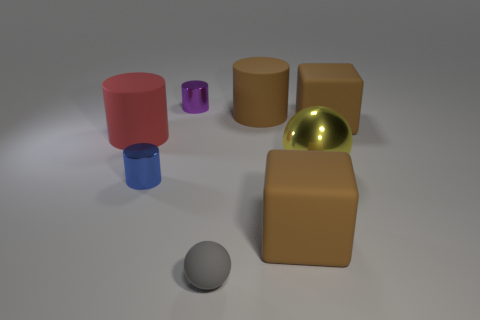In terms of spatial arrangement, how are the objects positioned relative to each other? The objects are scattered across the surface in a semi-organized fashion. The pink and beige cylinders form a loose triangular formation with the yellow metallic ball at the center. The small purple cylinder is placed to the left of the pink cylinder, while the blue cylinder rests near the lower edge of the arrangement. The grey sphere sits off to the side, suggesting both an element of randomness and thoughtful composition. 